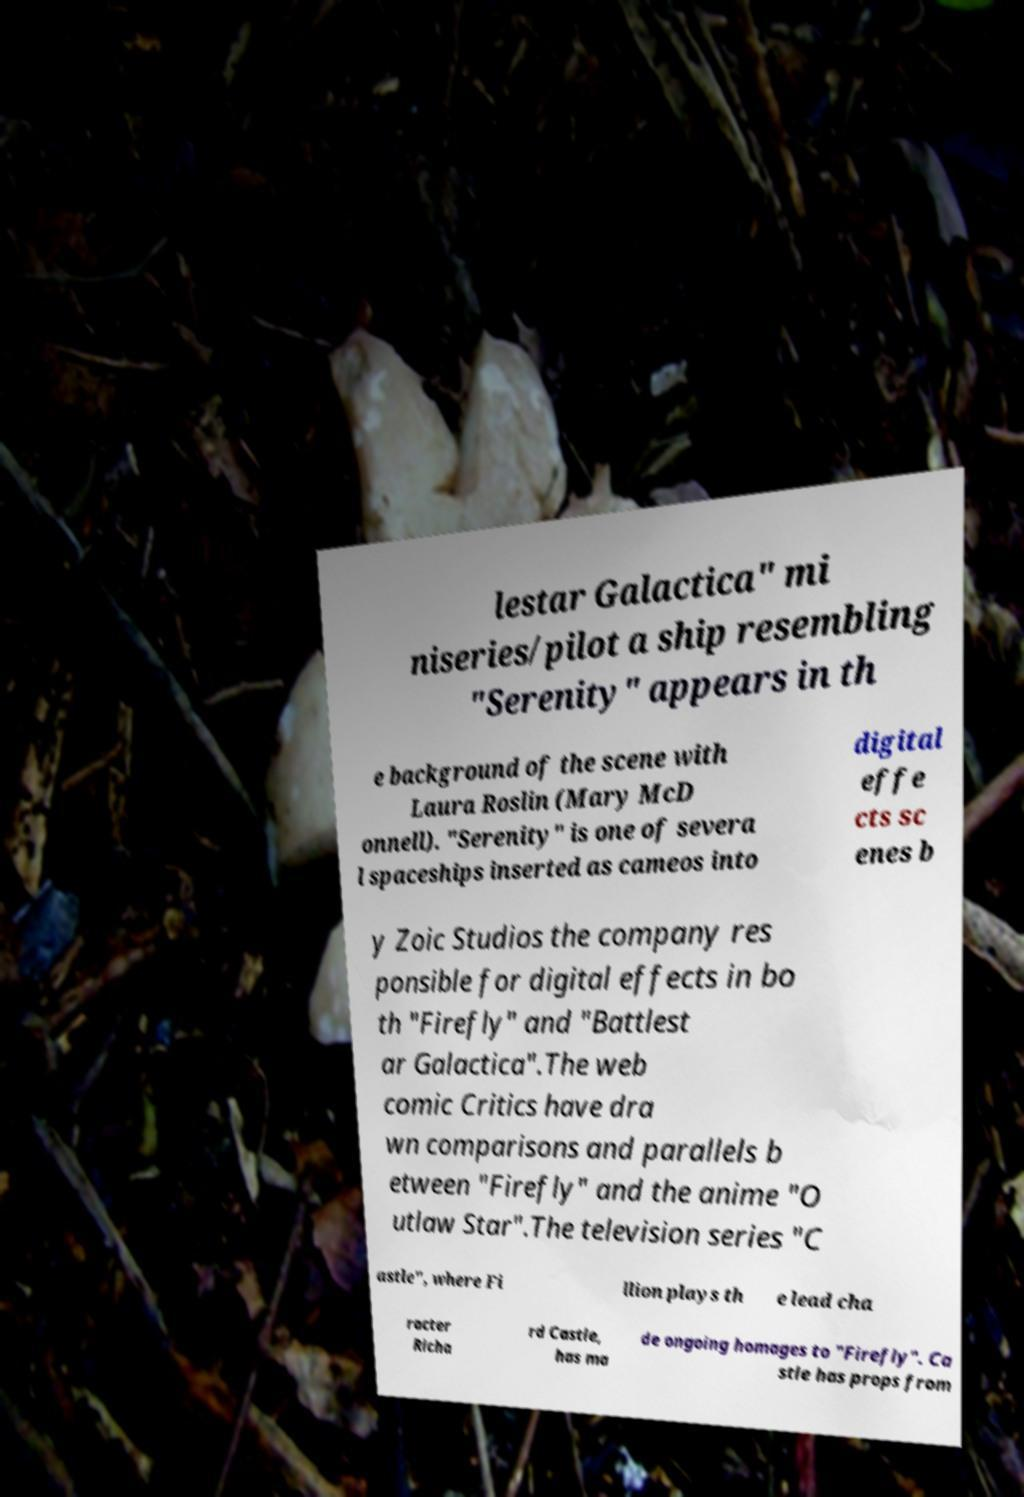Please read and relay the text visible in this image. What does it say? lestar Galactica" mi niseries/pilot a ship resembling "Serenity" appears in th e background of the scene with Laura Roslin (Mary McD onnell). "Serenity" is one of severa l spaceships inserted as cameos into digital effe cts sc enes b y Zoic Studios the company res ponsible for digital effects in bo th "Firefly" and "Battlest ar Galactica".The web comic Critics have dra wn comparisons and parallels b etween "Firefly" and the anime "O utlaw Star".The television series "C astle", where Fi llion plays th e lead cha racter Richa rd Castle, has ma de ongoing homages to "Firefly". Ca stle has props from 